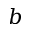<formula> <loc_0><loc_0><loc_500><loc_500>b</formula> 